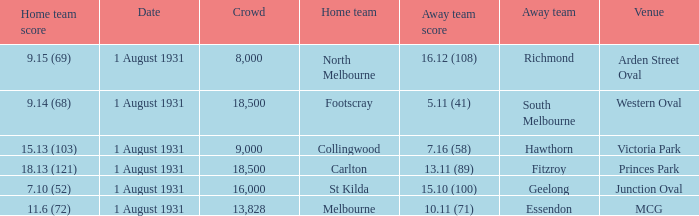What is the home team at the venue mcg? Melbourne. 